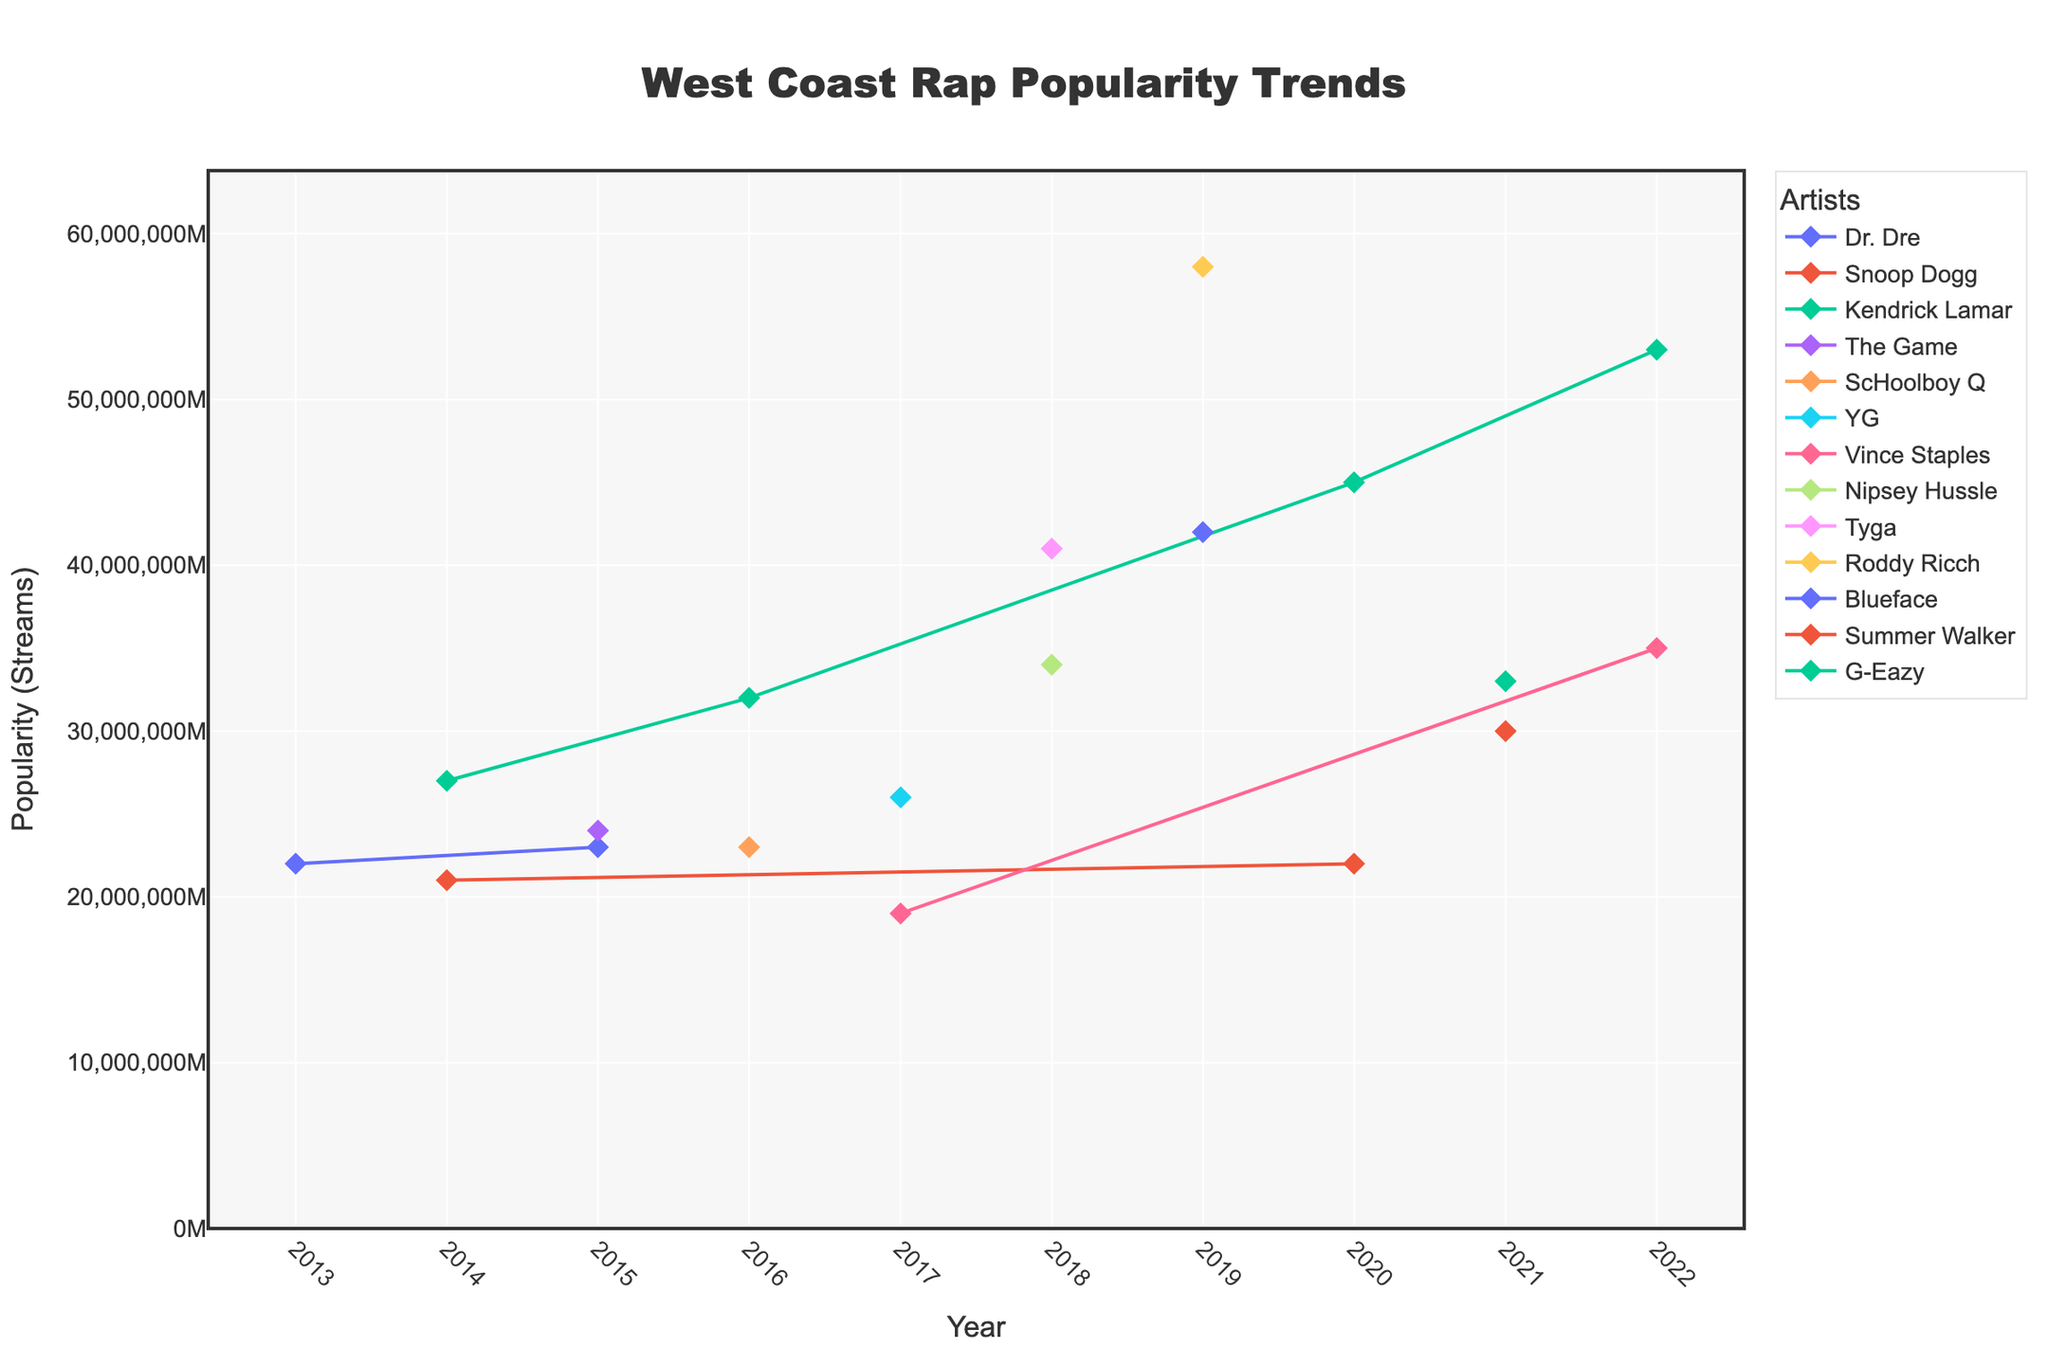What's the title of the plot? The title is usually located at the top of the plot. In this case, it's centered and written in a large, bold font.
Answer: West Coast Rap Popularity Trends Which artist has the highest popularity in 2019? Look at the year 2019 on the x-axis, then identify the artist with the highest y-value (popularity in streams) in that year.
Answer: Roddy Ricch In which year did Kendrick Lamar release the most popular song according to the plot? Identify all the data points related to Kendrick Lamar and find the year associated with the highest y-value (streams).
Answer: 2022 What is the range of popularity streams on the y-axis? The y-axis range can be determined by looking at the lower and upper bounds specified on the axis.
Answer: 0 to approximately 62 million How many unique artists are represented in the plot? The legend lists all unique artists. Count the number of distinct names.
Answer: 11 Which artist has the most consistent trend in terms of popularity over the years? Identify the artist whose data points (lines) show the least variability in y-values across different years. Consistency here means the smallest variation.
Answer: Dr. Dre What's the average popularity of songs released in 2016? Locate all the data points for 2016, sum their y-values (popularity), and divide by the number of data points in that year. Specifically, for Kendrick Lamar (32M) and ScHoolboy Q (23M), calculate as follows: (32M + 23M) / 2.
Answer: 27.5 million Between 2014 and 2016, which artist had the largest increase in popularity? Compare the popularity (y-values) of artists from 2014 to 2016. Calculate the difference for each artist with data points in both years (if available) and identify the largest increase.
Answer: Kendrick Lamar Which year has the highest collective popularity of songs for all artists? Sum the y-values for all data points in each year and identify the year with the highest total.
Answer: 2019 What was the popularity trend for Snoop Dogg from 2014 to 2020? Observe the Snoop Dogg data points and their positions from 2014 to 2020 to determine whether the trend is increasing, decreasing, or fluctuating.
Answer: Fluctuating 